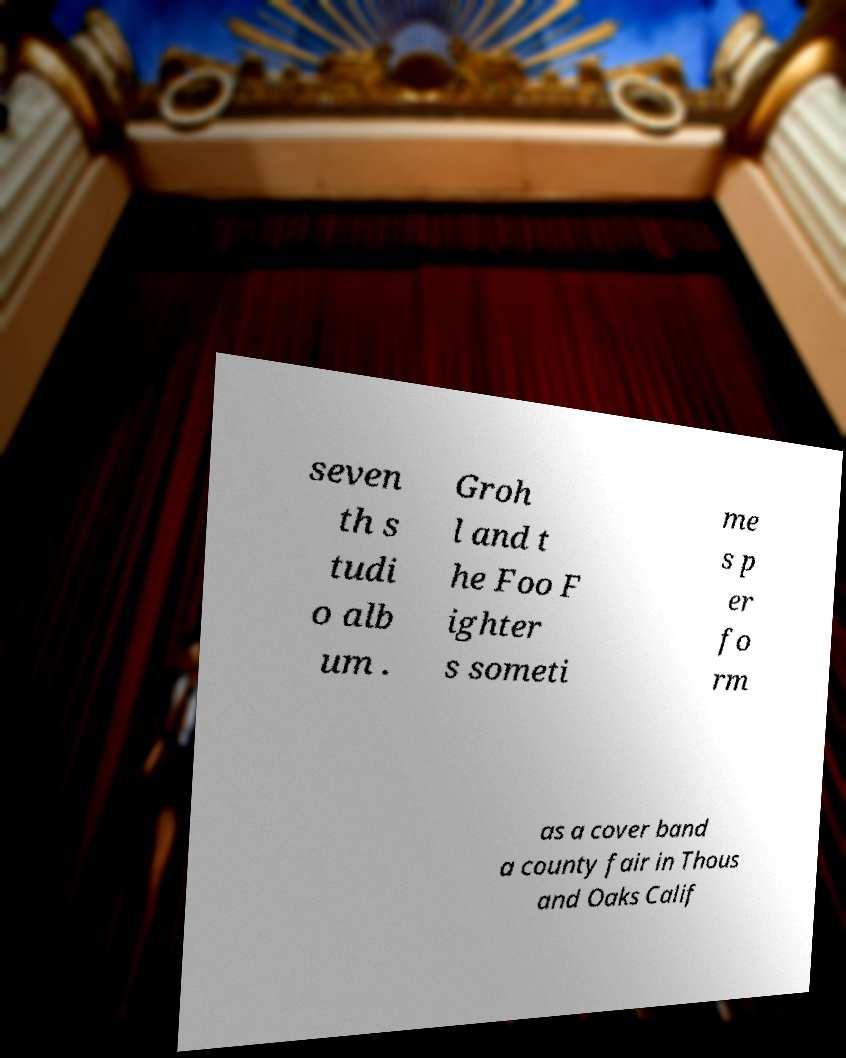Could you assist in decoding the text presented in this image and type it out clearly? seven th s tudi o alb um . Groh l and t he Foo F ighter s someti me s p er fo rm as a cover band a county fair in Thous and Oaks Calif 